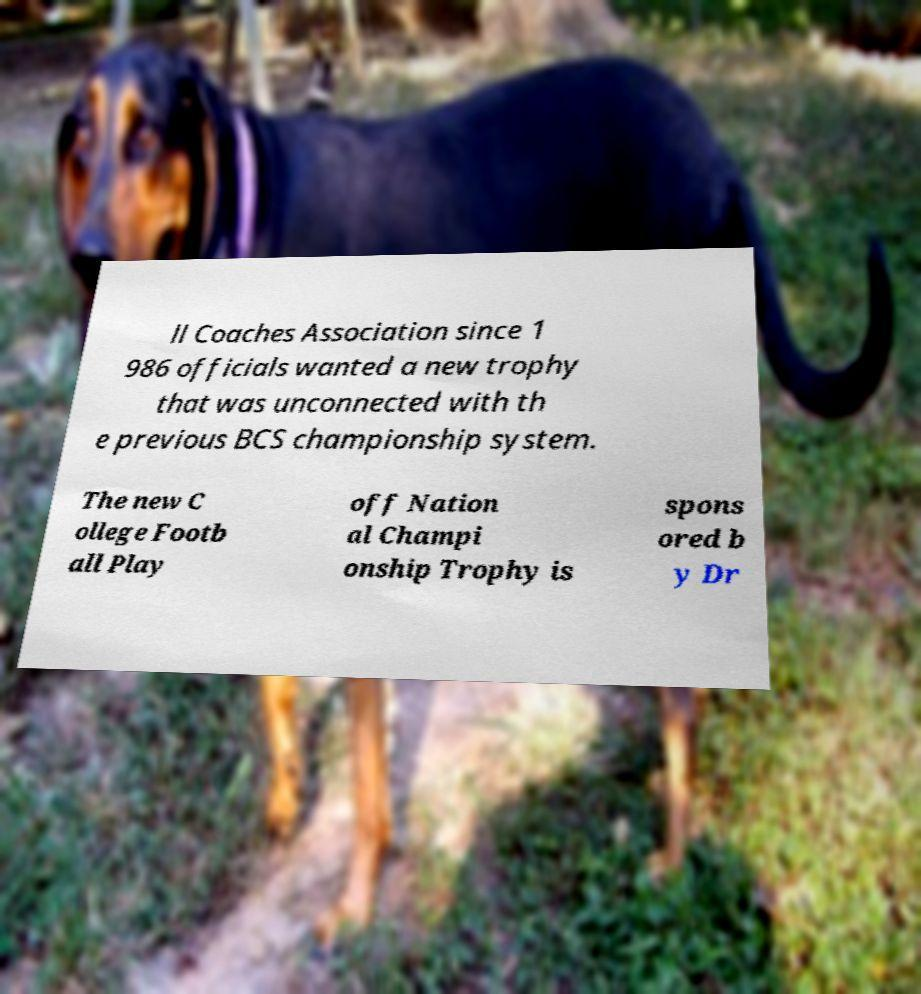Please identify and transcribe the text found in this image. ll Coaches Association since 1 986 officials wanted a new trophy that was unconnected with th e previous BCS championship system. The new C ollege Footb all Play off Nation al Champi onship Trophy is spons ored b y Dr 